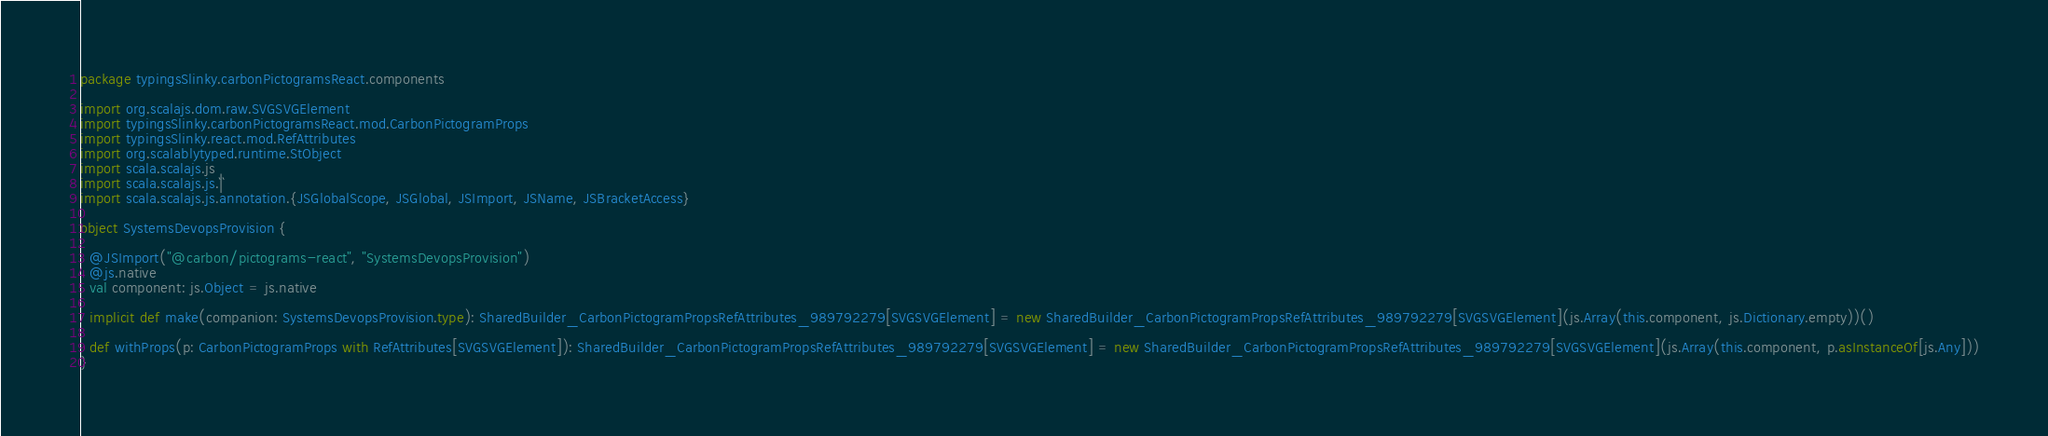<code> <loc_0><loc_0><loc_500><loc_500><_Scala_>package typingsSlinky.carbonPictogramsReact.components

import org.scalajs.dom.raw.SVGSVGElement
import typingsSlinky.carbonPictogramsReact.mod.CarbonPictogramProps
import typingsSlinky.react.mod.RefAttributes
import org.scalablytyped.runtime.StObject
import scala.scalajs.js
import scala.scalajs.js.`|`
import scala.scalajs.js.annotation.{JSGlobalScope, JSGlobal, JSImport, JSName, JSBracketAccess}

object SystemsDevopsProvision {
  
  @JSImport("@carbon/pictograms-react", "SystemsDevopsProvision")
  @js.native
  val component: js.Object = js.native
  
  implicit def make(companion: SystemsDevopsProvision.type): SharedBuilder_CarbonPictogramPropsRefAttributes_989792279[SVGSVGElement] = new SharedBuilder_CarbonPictogramPropsRefAttributes_989792279[SVGSVGElement](js.Array(this.component, js.Dictionary.empty))()
  
  def withProps(p: CarbonPictogramProps with RefAttributes[SVGSVGElement]): SharedBuilder_CarbonPictogramPropsRefAttributes_989792279[SVGSVGElement] = new SharedBuilder_CarbonPictogramPropsRefAttributes_989792279[SVGSVGElement](js.Array(this.component, p.asInstanceOf[js.Any]))
}
</code> 